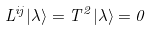Convert formula to latex. <formula><loc_0><loc_0><loc_500><loc_500>L ^ { i j } | \lambda \rangle = T ^ { 2 } | \lambda \rangle = 0</formula> 